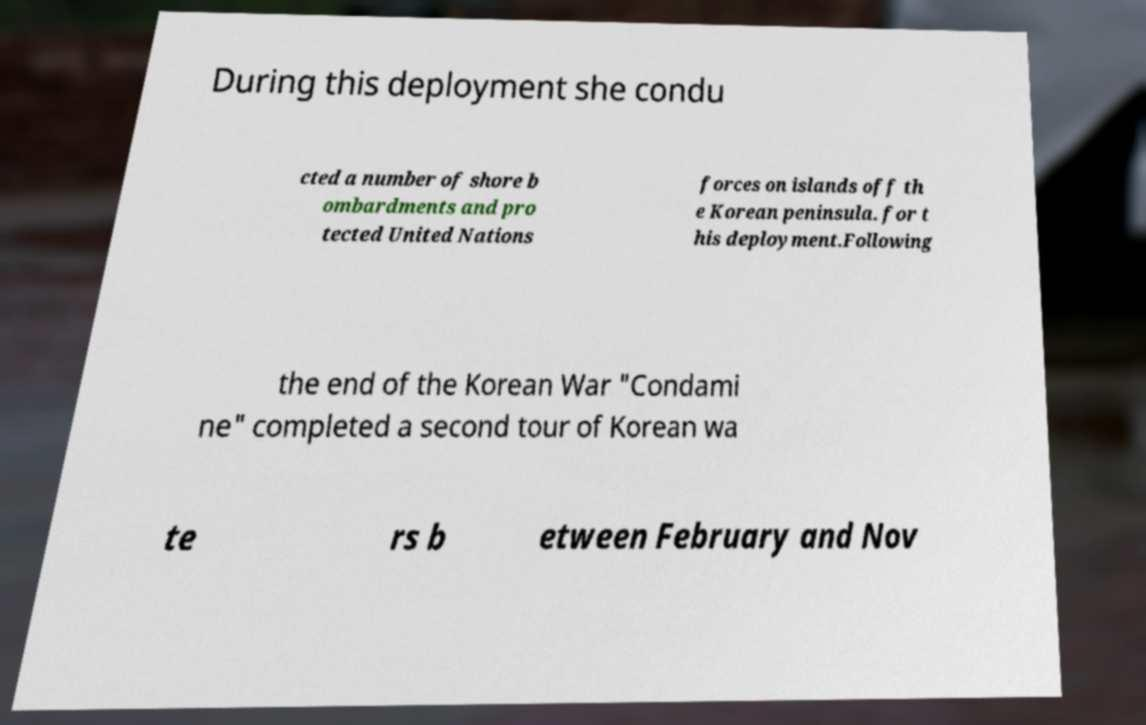I need the written content from this picture converted into text. Can you do that? During this deployment she condu cted a number of shore b ombardments and pro tected United Nations forces on islands off th e Korean peninsula. for t his deployment.Following the end of the Korean War "Condami ne" completed a second tour of Korean wa te rs b etween February and Nov 